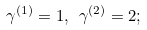<formula> <loc_0><loc_0><loc_500><loc_500>\gamma ^ { ( 1 ) } = 1 , \ \gamma ^ { ( 2 ) } = 2 ;</formula> 